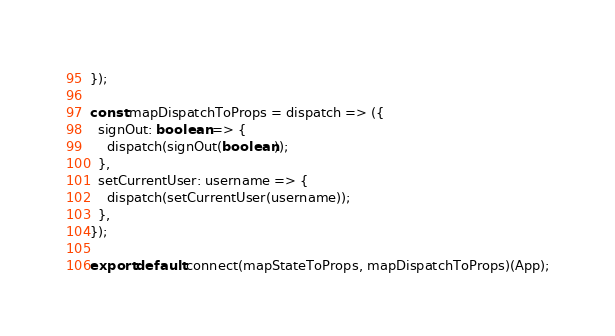<code> <loc_0><loc_0><loc_500><loc_500><_JavaScript_>});

const mapDispatchToProps = dispatch => ({
  signOut: boolean => {
    dispatch(signOut(boolean));
  },
  setCurrentUser: username => {
    dispatch(setCurrentUser(username));
  },
});

export default connect(mapStateToProps, mapDispatchToProps)(App);
</code> 